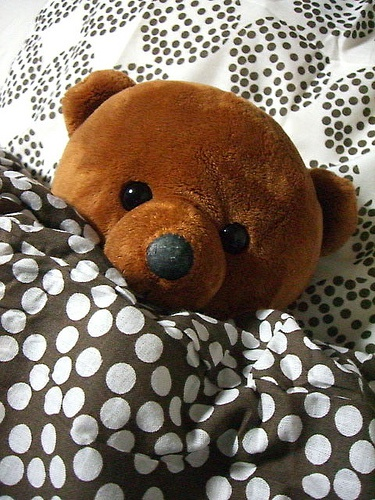Describe the objects in this image and their specific colors. I can see bed in white, black, maroon, gray, and darkgray tones and teddy bear in lightgray, maroon, black, and brown tones in this image. 